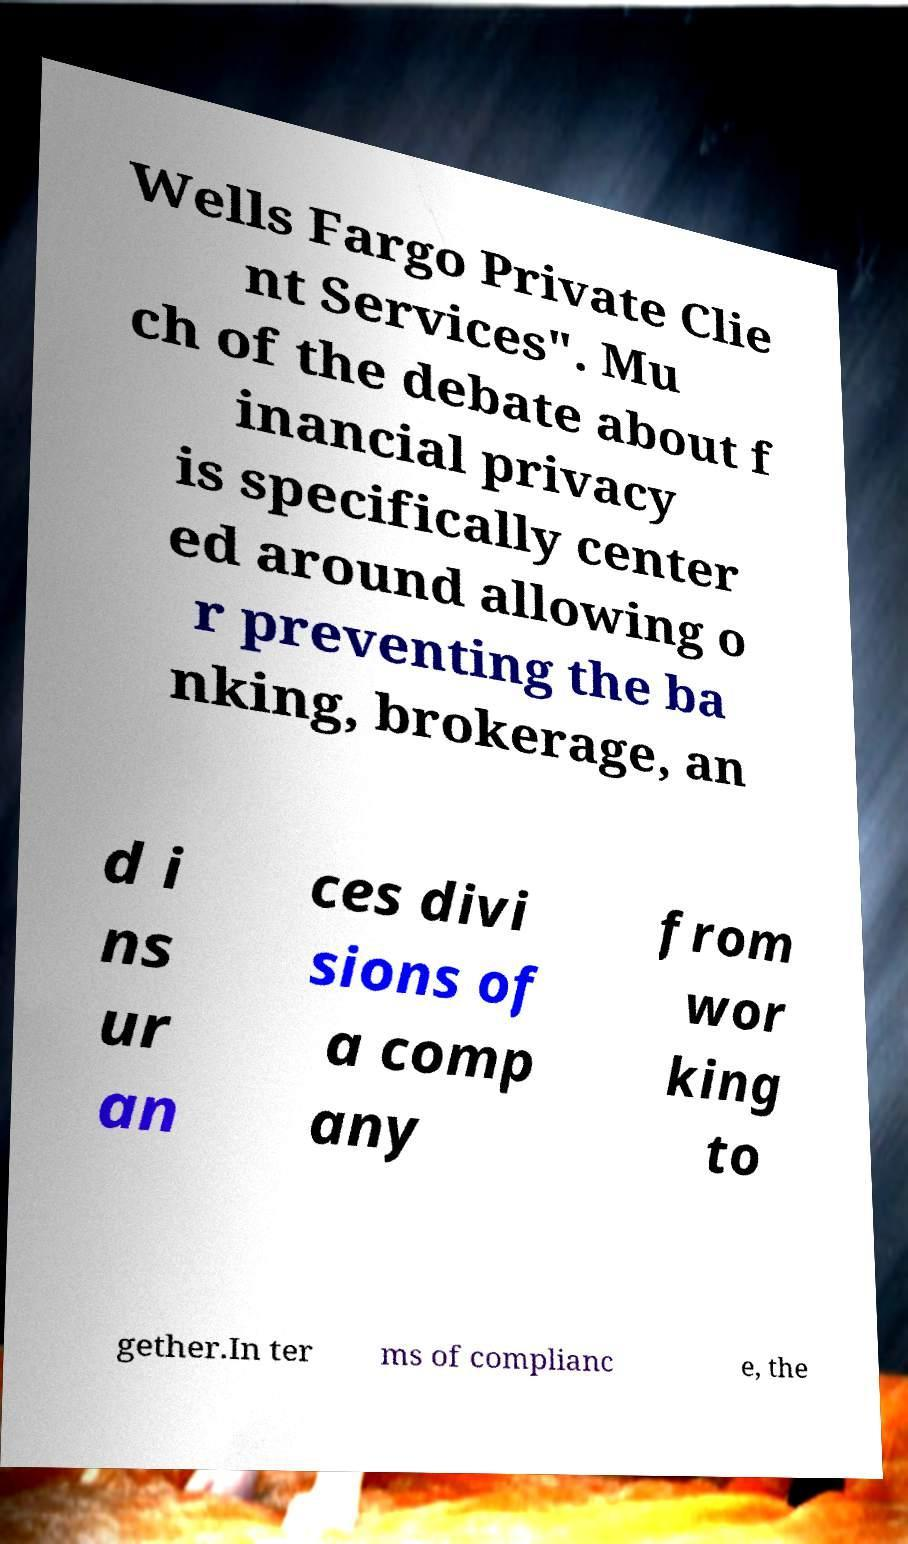What messages or text are displayed in this image? I need them in a readable, typed format. Wells Fargo Private Clie nt Services". Mu ch of the debate about f inancial privacy is specifically center ed around allowing o r preventing the ba nking, brokerage, an d i ns ur an ces divi sions of a comp any from wor king to gether.In ter ms of complianc e, the 